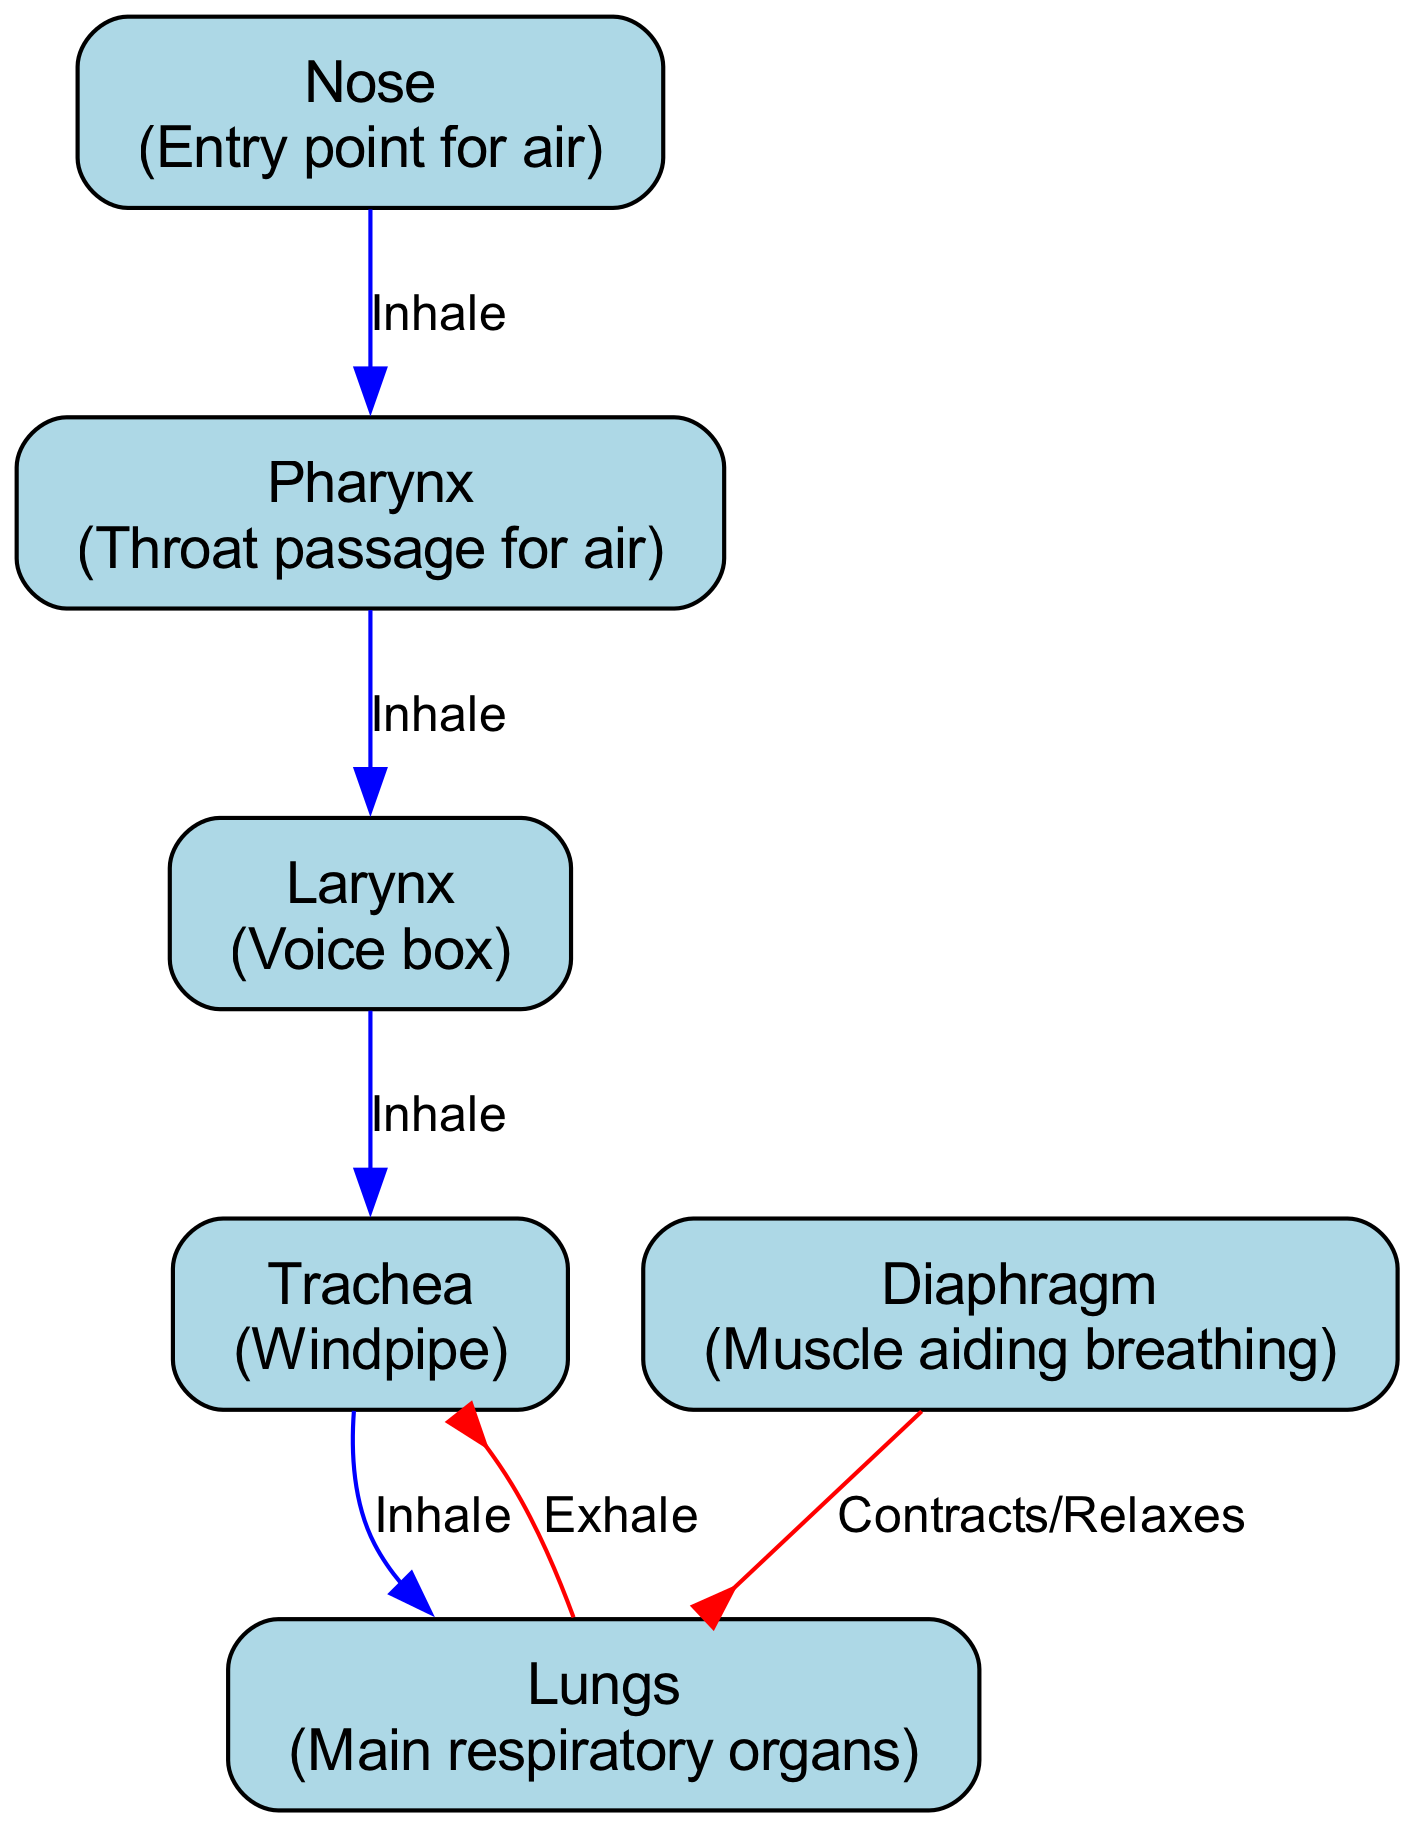What is the entry point for air? The diagram labels "Nose" as the entry point for air, indicating the first organ where inhalation begins.
Answer: Nose How many major organs are indicated in the diagram? Counting the nodes listed, there are six major organs: Nose, Pharynx, Larynx, Trachea, Lungs, and Diaphragm.
Answer: 6 Which direction does air flow from the Trachea to the Lungs? The diagram shows an edge labeled "Inhale" going down from the Trachea to the Lungs, indicating the downward direction of airflow during inhalation.
Answer: Down What is the role of the Diaphragm according to the diagram? The Diaphragm is described as the muscle aiding breathing, and it contracts and relaxes to assist in the process of breathing as indicated in the edge label.
Answer: Aiding breathing How does airflow change during exhalation compared to inhalation? During inhalation, the airflow direction is consistently downwards from the Nose to the Lungs, while during exhalation, the airflow is upwards from the Lungs back to the Trachea.
Answer: Up vs. Down Which organ acts as the voice box? The diagram explicitly labels the "Larynx" as the voice box, identifying its specific role in the respiratory system.
Answer: Larynx What is the flow of air from Nose to Larynx labeled as? The connection from Nose to Larynx is labeled "Inhale," indicating the airflow during the inhalation process from one organ to the next.
Answer: Inhale Which organ connects directly to both the Lungs and the Larynx in the airflow diagram? Trachea connects directly from the Larynx and then goes to the Lungs, serving as a crucial passage for airflow in both directions.
Answer: Trachea 